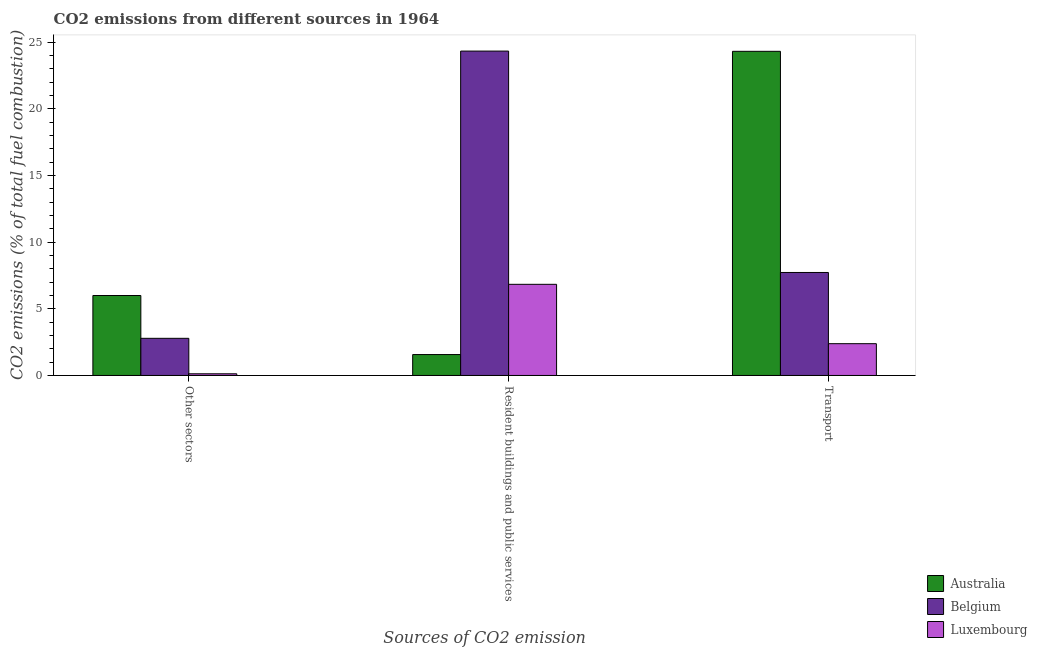How many different coloured bars are there?
Provide a short and direct response. 3. Are the number of bars per tick equal to the number of legend labels?
Your answer should be very brief. Yes. How many bars are there on the 1st tick from the right?
Provide a succinct answer. 3. What is the label of the 2nd group of bars from the left?
Provide a succinct answer. Resident buildings and public services. What is the percentage of co2 emissions from transport in Australia?
Give a very brief answer. 24.3. Across all countries, what is the maximum percentage of co2 emissions from transport?
Offer a terse response. 24.3. Across all countries, what is the minimum percentage of co2 emissions from resident buildings and public services?
Ensure brevity in your answer.  1.57. In which country was the percentage of co2 emissions from resident buildings and public services maximum?
Keep it short and to the point. Belgium. In which country was the percentage of co2 emissions from other sectors minimum?
Ensure brevity in your answer.  Luxembourg. What is the total percentage of co2 emissions from transport in the graph?
Your answer should be compact. 34.41. What is the difference between the percentage of co2 emissions from transport in Luxembourg and that in Australia?
Make the answer very short. -21.92. What is the difference between the percentage of co2 emissions from transport in Australia and the percentage of co2 emissions from resident buildings and public services in Belgium?
Provide a short and direct response. -0.02. What is the average percentage of co2 emissions from transport per country?
Provide a succinct answer. 11.47. What is the difference between the percentage of co2 emissions from other sectors and percentage of co2 emissions from transport in Luxembourg?
Make the answer very short. -2.26. What is the ratio of the percentage of co2 emissions from transport in Australia to that in Luxembourg?
Provide a short and direct response. 10.2. Is the percentage of co2 emissions from resident buildings and public services in Belgium less than that in Luxembourg?
Your answer should be compact. No. Is the difference between the percentage of co2 emissions from transport in Luxembourg and Australia greater than the difference between the percentage of co2 emissions from other sectors in Luxembourg and Australia?
Make the answer very short. No. What is the difference between the highest and the second highest percentage of co2 emissions from resident buildings and public services?
Provide a succinct answer. 17.49. What is the difference between the highest and the lowest percentage of co2 emissions from transport?
Your answer should be compact. 21.92. Is the sum of the percentage of co2 emissions from other sectors in Belgium and Australia greater than the maximum percentage of co2 emissions from transport across all countries?
Offer a very short reply. No. How many bars are there?
Offer a terse response. 9. Does the graph contain any zero values?
Give a very brief answer. No. Does the graph contain grids?
Provide a succinct answer. No. Where does the legend appear in the graph?
Make the answer very short. Bottom right. What is the title of the graph?
Offer a very short reply. CO2 emissions from different sources in 1964. Does "Guyana" appear as one of the legend labels in the graph?
Ensure brevity in your answer.  No. What is the label or title of the X-axis?
Your answer should be very brief. Sources of CO2 emission. What is the label or title of the Y-axis?
Ensure brevity in your answer.  CO2 emissions (% of total fuel combustion). What is the CO2 emissions (% of total fuel combustion) of Australia in Other sectors?
Make the answer very short. 6. What is the CO2 emissions (% of total fuel combustion) of Belgium in Other sectors?
Keep it short and to the point. 2.78. What is the CO2 emissions (% of total fuel combustion) in Luxembourg in Other sectors?
Keep it short and to the point. 0.13. What is the CO2 emissions (% of total fuel combustion) of Australia in Resident buildings and public services?
Ensure brevity in your answer.  1.57. What is the CO2 emissions (% of total fuel combustion) in Belgium in Resident buildings and public services?
Provide a short and direct response. 24.32. What is the CO2 emissions (% of total fuel combustion) in Luxembourg in Resident buildings and public services?
Make the answer very short. 6.83. What is the CO2 emissions (% of total fuel combustion) of Australia in Transport?
Ensure brevity in your answer.  24.3. What is the CO2 emissions (% of total fuel combustion) of Belgium in Transport?
Your answer should be compact. 7.72. What is the CO2 emissions (% of total fuel combustion) in Luxembourg in Transport?
Provide a succinct answer. 2.38. Across all Sources of CO2 emission, what is the maximum CO2 emissions (% of total fuel combustion) in Australia?
Provide a succinct answer. 24.3. Across all Sources of CO2 emission, what is the maximum CO2 emissions (% of total fuel combustion) of Belgium?
Your response must be concise. 24.32. Across all Sources of CO2 emission, what is the maximum CO2 emissions (% of total fuel combustion) of Luxembourg?
Your response must be concise. 6.83. Across all Sources of CO2 emission, what is the minimum CO2 emissions (% of total fuel combustion) in Australia?
Offer a very short reply. 1.57. Across all Sources of CO2 emission, what is the minimum CO2 emissions (% of total fuel combustion) in Belgium?
Provide a short and direct response. 2.78. Across all Sources of CO2 emission, what is the minimum CO2 emissions (% of total fuel combustion) in Luxembourg?
Provide a short and direct response. 0.13. What is the total CO2 emissions (% of total fuel combustion) of Australia in the graph?
Ensure brevity in your answer.  31.87. What is the total CO2 emissions (% of total fuel combustion) in Belgium in the graph?
Your answer should be compact. 34.83. What is the total CO2 emissions (% of total fuel combustion) of Luxembourg in the graph?
Ensure brevity in your answer.  9.34. What is the difference between the CO2 emissions (% of total fuel combustion) in Australia in Other sectors and that in Resident buildings and public services?
Make the answer very short. 4.43. What is the difference between the CO2 emissions (% of total fuel combustion) in Belgium in Other sectors and that in Resident buildings and public services?
Your answer should be very brief. -21.54. What is the difference between the CO2 emissions (% of total fuel combustion) in Luxembourg in Other sectors and that in Resident buildings and public services?
Provide a succinct answer. -6.71. What is the difference between the CO2 emissions (% of total fuel combustion) in Australia in Other sectors and that in Transport?
Give a very brief answer. -18.31. What is the difference between the CO2 emissions (% of total fuel combustion) in Belgium in Other sectors and that in Transport?
Ensure brevity in your answer.  -4.94. What is the difference between the CO2 emissions (% of total fuel combustion) of Luxembourg in Other sectors and that in Transport?
Provide a short and direct response. -2.26. What is the difference between the CO2 emissions (% of total fuel combustion) of Australia in Resident buildings and public services and that in Transport?
Ensure brevity in your answer.  -22.74. What is the difference between the CO2 emissions (% of total fuel combustion) in Belgium in Resident buildings and public services and that in Transport?
Your response must be concise. 16.6. What is the difference between the CO2 emissions (% of total fuel combustion) in Luxembourg in Resident buildings and public services and that in Transport?
Provide a succinct answer. 4.45. What is the difference between the CO2 emissions (% of total fuel combustion) of Australia in Other sectors and the CO2 emissions (% of total fuel combustion) of Belgium in Resident buildings and public services?
Keep it short and to the point. -18.33. What is the difference between the CO2 emissions (% of total fuel combustion) of Australia in Other sectors and the CO2 emissions (% of total fuel combustion) of Luxembourg in Resident buildings and public services?
Give a very brief answer. -0.84. What is the difference between the CO2 emissions (% of total fuel combustion) of Belgium in Other sectors and the CO2 emissions (% of total fuel combustion) of Luxembourg in Resident buildings and public services?
Offer a terse response. -4.05. What is the difference between the CO2 emissions (% of total fuel combustion) in Australia in Other sectors and the CO2 emissions (% of total fuel combustion) in Belgium in Transport?
Your answer should be compact. -1.73. What is the difference between the CO2 emissions (% of total fuel combustion) in Australia in Other sectors and the CO2 emissions (% of total fuel combustion) in Luxembourg in Transport?
Your answer should be compact. 3.61. What is the difference between the CO2 emissions (% of total fuel combustion) in Belgium in Other sectors and the CO2 emissions (% of total fuel combustion) in Luxembourg in Transport?
Ensure brevity in your answer.  0.4. What is the difference between the CO2 emissions (% of total fuel combustion) in Australia in Resident buildings and public services and the CO2 emissions (% of total fuel combustion) in Belgium in Transport?
Your answer should be very brief. -6.15. What is the difference between the CO2 emissions (% of total fuel combustion) of Australia in Resident buildings and public services and the CO2 emissions (% of total fuel combustion) of Luxembourg in Transport?
Your answer should be compact. -0.81. What is the difference between the CO2 emissions (% of total fuel combustion) in Belgium in Resident buildings and public services and the CO2 emissions (% of total fuel combustion) in Luxembourg in Transport?
Ensure brevity in your answer.  21.94. What is the average CO2 emissions (% of total fuel combustion) in Australia per Sources of CO2 emission?
Offer a very short reply. 10.62. What is the average CO2 emissions (% of total fuel combustion) of Belgium per Sources of CO2 emission?
Your response must be concise. 11.61. What is the average CO2 emissions (% of total fuel combustion) in Luxembourg per Sources of CO2 emission?
Make the answer very short. 3.11. What is the difference between the CO2 emissions (% of total fuel combustion) in Australia and CO2 emissions (% of total fuel combustion) in Belgium in Other sectors?
Give a very brief answer. 3.21. What is the difference between the CO2 emissions (% of total fuel combustion) of Australia and CO2 emissions (% of total fuel combustion) of Luxembourg in Other sectors?
Give a very brief answer. 5.87. What is the difference between the CO2 emissions (% of total fuel combustion) of Belgium and CO2 emissions (% of total fuel combustion) of Luxembourg in Other sectors?
Your answer should be very brief. 2.66. What is the difference between the CO2 emissions (% of total fuel combustion) in Australia and CO2 emissions (% of total fuel combustion) in Belgium in Resident buildings and public services?
Keep it short and to the point. -22.75. What is the difference between the CO2 emissions (% of total fuel combustion) in Australia and CO2 emissions (% of total fuel combustion) in Luxembourg in Resident buildings and public services?
Provide a succinct answer. -5.27. What is the difference between the CO2 emissions (% of total fuel combustion) in Belgium and CO2 emissions (% of total fuel combustion) in Luxembourg in Resident buildings and public services?
Your answer should be very brief. 17.49. What is the difference between the CO2 emissions (% of total fuel combustion) of Australia and CO2 emissions (% of total fuel combustion) of Belgium in Transport?
Offer a very short reply. 16.58. What is the difference between the CO2 emissions (% of total fuel combustion) of Australia and CO2 emissions (% of total fuel combustion) of Luxembourg in Transport?
Give a very brief answer. 21.92. What is the difference between the CO2 emissions (% of total fuel combustion) of Belgium and CO2 emissions (% of total fuel combustion) of Luxembourg in Transport?
Your response must be concise. 5.34. What is the ratio of the CO2 emissions (% of total fuel combustion) of Australia in Other sectors to that in Resident buildings and public services?
Provide a succinct answer. 3.82. What is the ratio of the CO2 emissions (% of total fuel combustion) in Belgium in Other sectors to that in Resident buildings and public services?
Your answer should be very brief. 0.11. What is the ratio of the CO2 emissions (% of total fuel combustion) of Luxembourg in Other sectors to that in Resident buildings and public services?
Offer a terse response. 0.02. What is the ratio of the CO2 emissions (% of total fuel combustion) of Australia in Other sectors to that in Transport?
Your response must be concise. 0.25. What is the ratio of the CO2 emissions (% of total fuel combustion) of Belgium in Other sectors to that in Transport?
Offer a very short reply. 0.36. What is the ratio of the CO2 emissions (% of total fuel combustion) in Luxembourg in Other sectors to that in Transport?
Your answer should be compact. 0.05. What is the ratio of the CO2 emissions (% of total fuel combustion) of Australia in Resident buildings and public services to that in Transport?
Keep it short and to the point. 0.06. What is the ratio of the CO2 emissions (% of total fuel combustion) in Belgium in Resident buildings and public services to that in Transport?
Keep it short and to the point. 3.15. What is the ratio of the CO2 emissions (% of total fuel combustion) of Luxembourg in Resident buildings and public services to that in Transport?
Offer a terse response. 2.87. What is the difference between the highest and the second highest CO2 emissions (% of total fuel combustion) of Australia?
Provide a short and direct response. 18.31. What is the difference between the highest and the second highest CO2 emissions (% of total fuel combustion) of Belgium?
Your answer should be compact. 16.6. What is the difference between the highest and the second highest CO2 emissions (% of total fuel combustion) in Luxembourg?
Ensure brevity in your answer.  4.45. What is the difference between the highest and the lowest CO2 emissions (% of total fuel combustion) in Australia?
Ensure brevity in your answer.  22.74. What is the difference between the highest and the lowest CO2 emissions (% of total fuel combustion) in Belgium?
Your response must be concise. 21.54. What is the difference between the highest and the lowest CO2 emissions (% of total fuel combustion) of Luxembourg?
Your response must be concise. 6.71. 